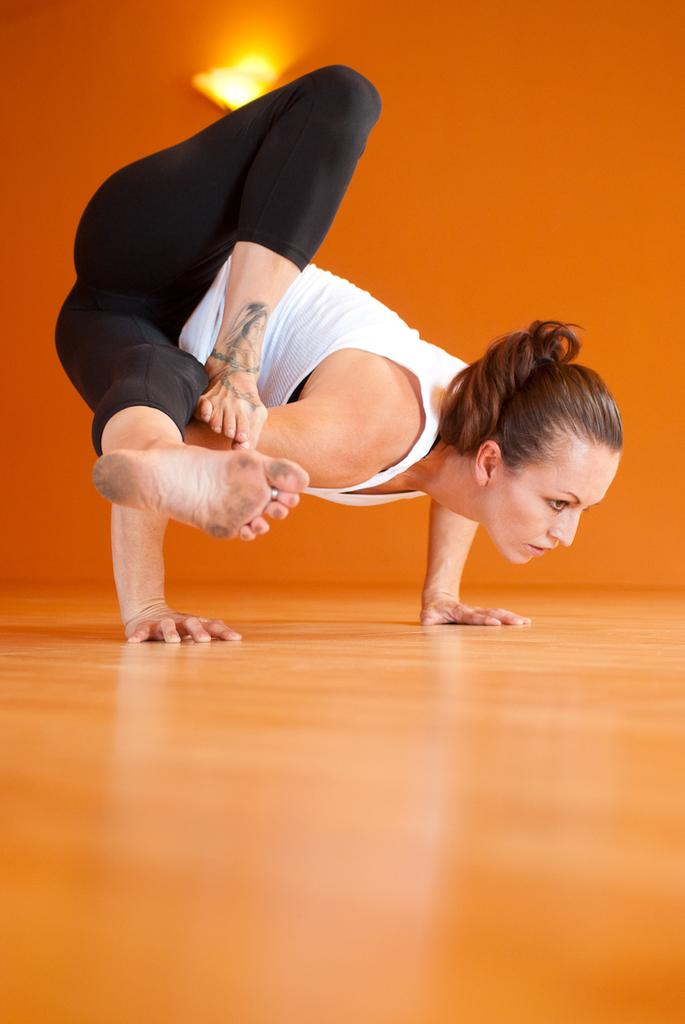What is the main subject of the image? The main subject of the image is a woman. What is the woman doing in the image? The woman is performing a yoga Aasan. What type of detail can be seen on the woman's clothing in the image? There is no specific detail mentioned on the woman's clothing in the provided facts. What type of meal is the woman eating while performing the yoga Aasan in the image? There is no meal present in the image; the woman is performing a yoga Aasan. Can you see a monkey in the image? There is no mention of a monkey in the provided facts, so it cannot be determined if one is present in the image. 